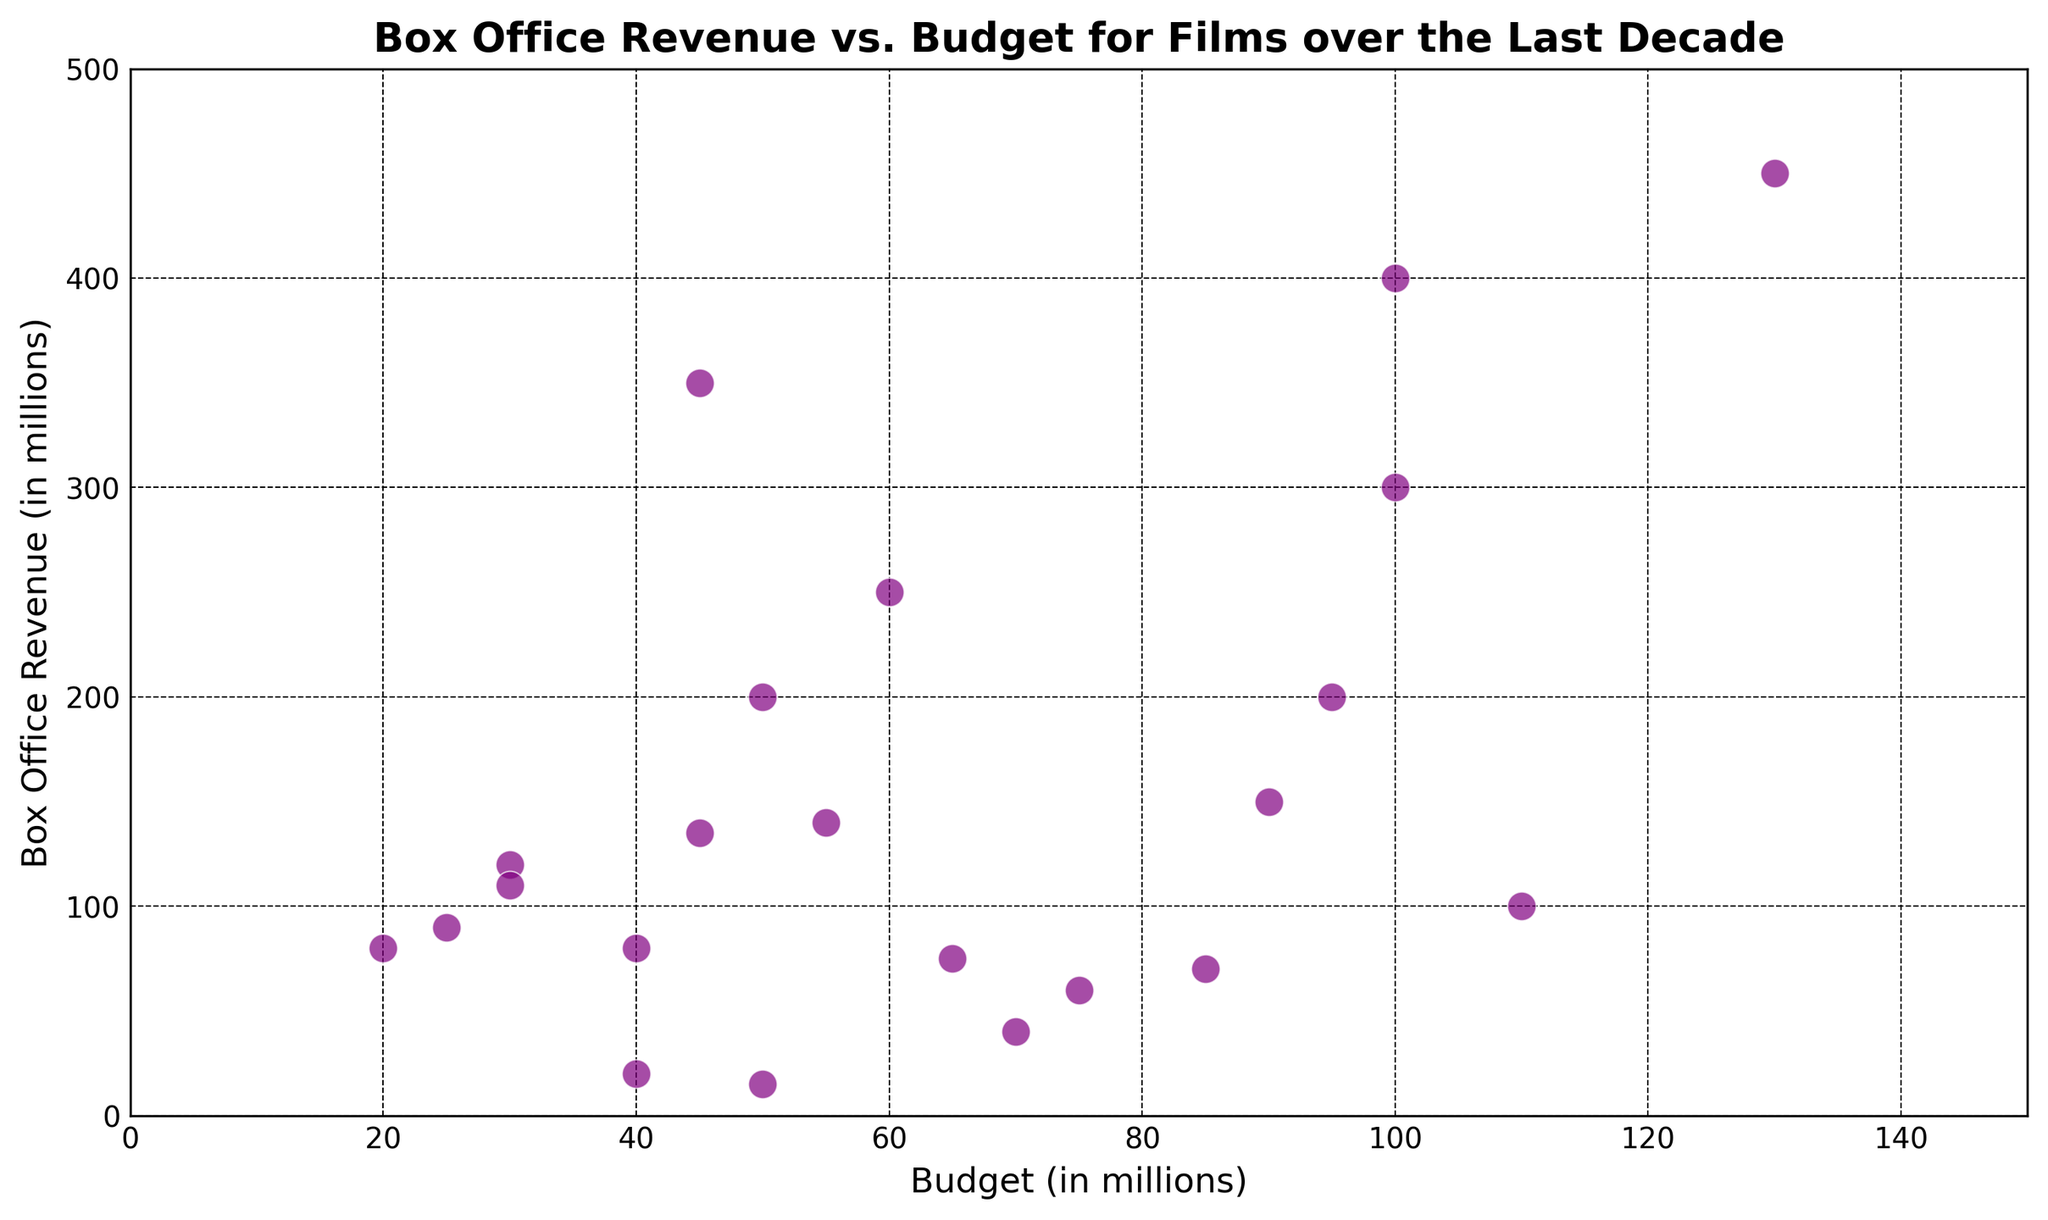What's the highest Box Office Revenue and its corresponding Budget? Looking at the scatter plot visually, the highest point on the y-axis represents the highest Box Office Revenue, which is around 450 million with a corresponding budget around 130 million for Film O in 2016.
Answer: 450 million, 130 million Which film had a budget closest to 100 million and what was its revenue? By identifying the points clustered around the Budget axis at approximately 100 million, we can see that Film I in 2021 had a budget close to 100 million, and a revenue of approximately 100 million.
Answer: Film I, 100 million How many films had a Box Office Revenue greater than their Budget? By checking the points above the diagonal line where Box Office Revenue equals the Budget (y = x line), count the points to find the films. Films A, B, D, F, H, L, N, O, Q, S, T, and U are above this line, indicating 12 films made more revenue than their budget.
Answer: 12 films What is the average budget of films with a Box Office Revenue greater than 200 million? Identify films with revenue greater than 200 million (Films A, D, F, L, O, U), then sum their budgets (50 + 100 + 60 + 45 + 130 + 100 = 485). Divide by the number of films (6) to get the average (485/6 ≈ 80.83 million).
Answer: 80.83 million Which film in 2017 had the lowest revenue and what was its budget? From the scatter plot, locate the points for films in 2017 and find the lowest point on the y-axis, which corresponds to Film P with the lowest revenue of around 15 million. The budget for Film P is about 50 million.
Answer: Film P, 50 million Compare the budgets of the films with the highest and lowest Box Office Revenues. Visually find the highest and lowest points on the y-axis (450 million and 15 million). The corresponding budgets are 130 million and 50 million for Films O and P respectively.
Answer: 130 million vs 50 million How many films had a budget of less than 50 million and what was their average Box Office Revenue? Count the number of points with budgets less than 50 million (Films B, E, H, N, S, V, 6 films). Sum their revenues (120 + 20 + 80 + 90 + 110 + 80 = 500 million). Divide by the number of films (500/6 ≈ 83.33 million).
Answer: 6 films, 83.33 million Which year had the highest number of films with a budget above 70 million? Count points above 70 million on the budget axis for each year. The year 2019 had 2 films (Films G and Q), others had fewer than 2.
Answer: 2019 